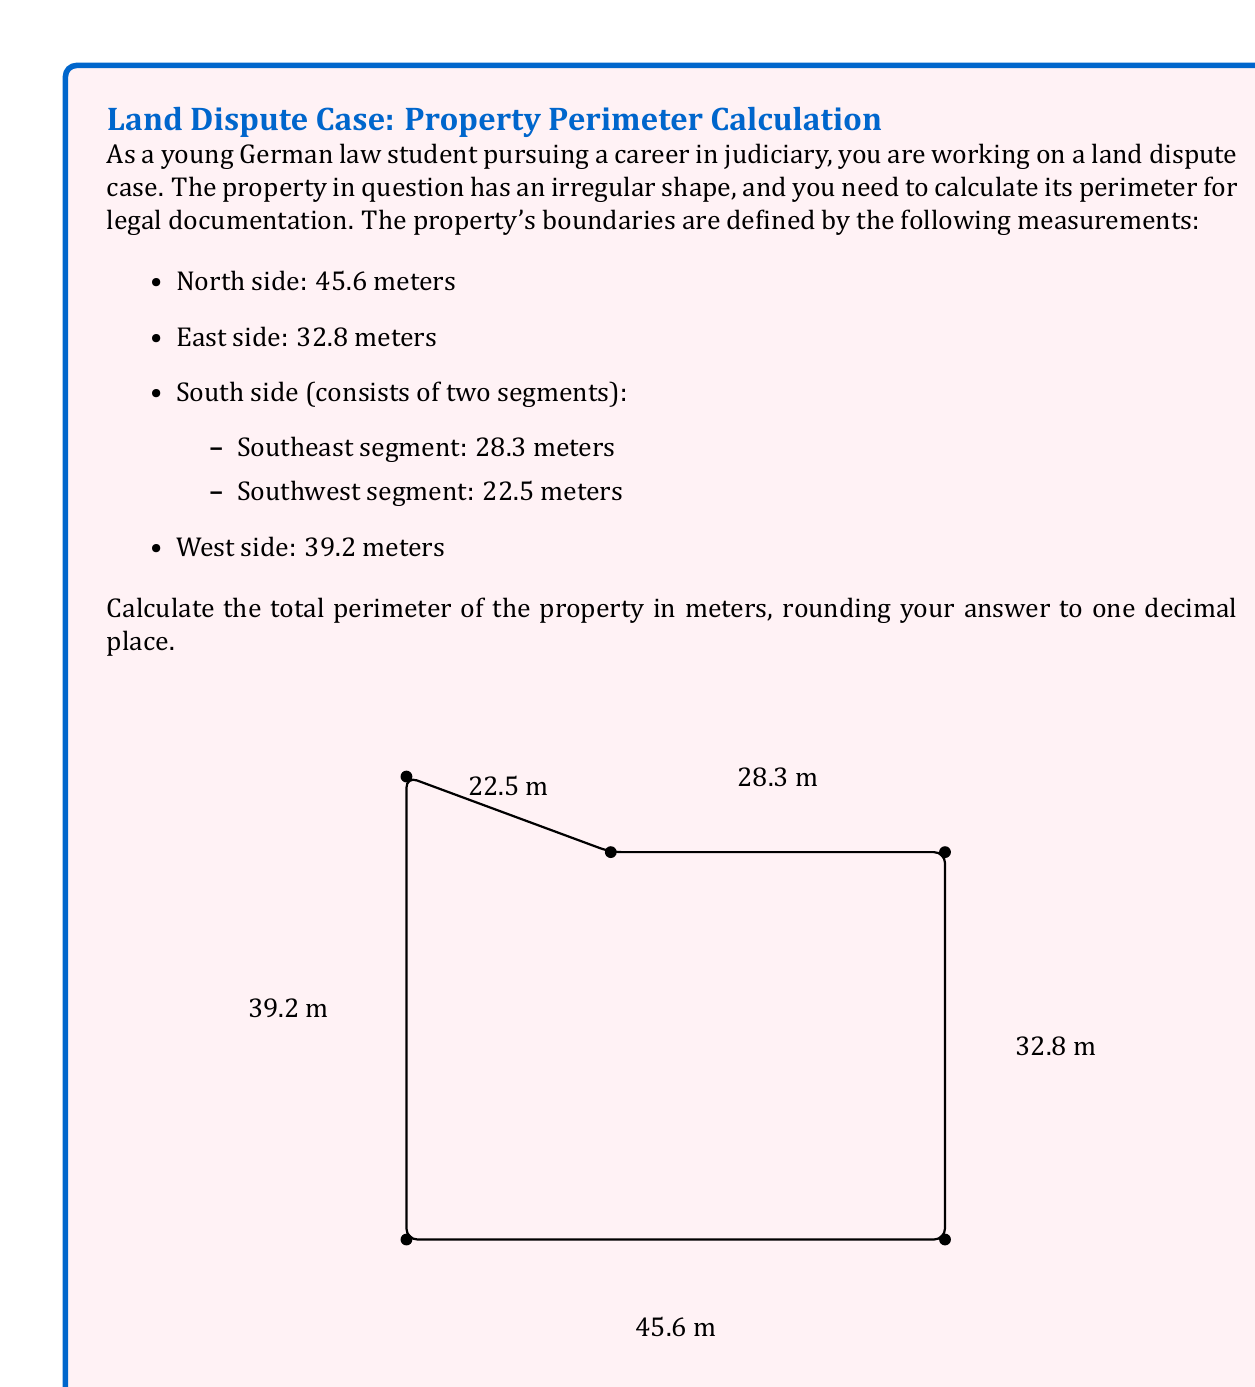Give your solution to this math problem. To calculate the perimeter of the irregularly shaped property, we need to sum up all the side lengths. Let's break it down step by step:

1. North side: 45.6 meters
2. East side: 32.8 meters
3. South side:
   a. Southeast segment: 28.3 meters
   b. Southwest segment: 22.5 meters
4. West side: 39.2 meters

Now, let's add all these lengths together:

$$\text{Perimeter} = 45.6 + 32.8 + 28.3 + 22.5 + 39.2$$

$$\text{Perimeter} = 168.4 \text{ meters}$$

Since we're asked to round to one decimal place, our final answer will be 168.4 meters.

This calculation is crucial for accurately documenting the property's dimensions in the land dispute case, ensuring that all parties involved have a clear understanding of the property's boundaries.
Answer: $168.4 \text{ meters}$ 